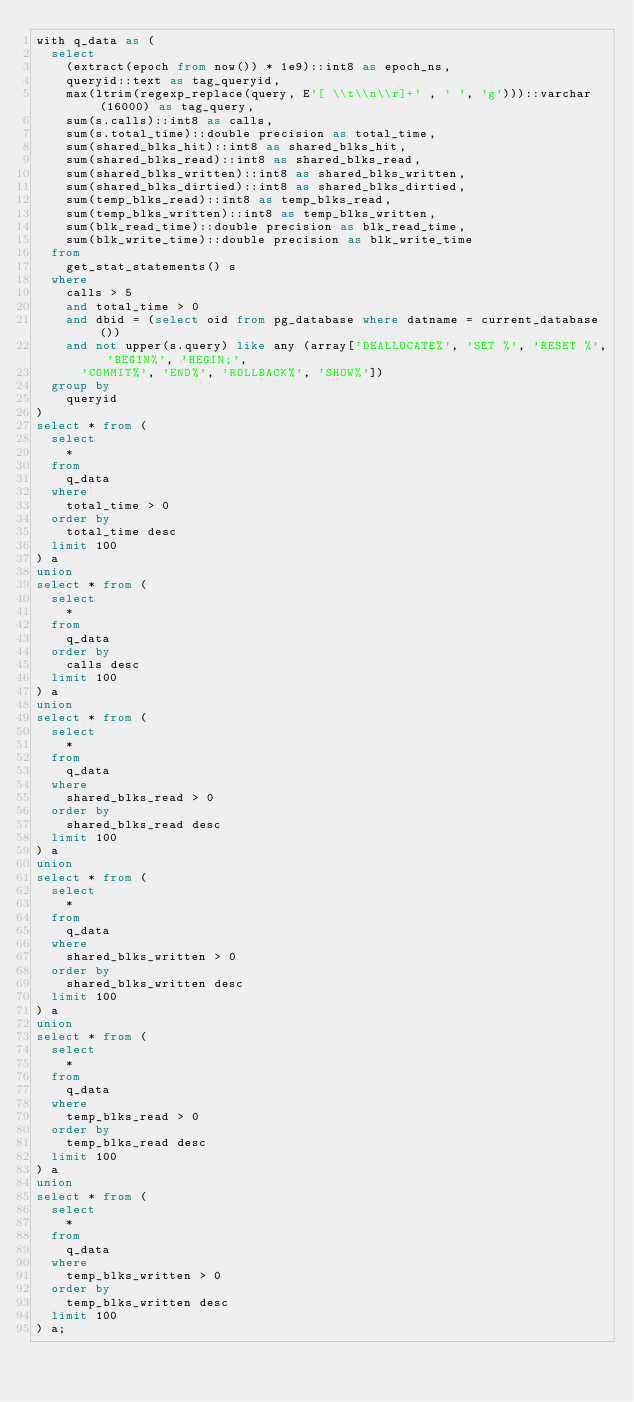Convert code to text. <code><loc_0><loc_0><loc_500><loc_500><_SQL_>with q_data as (
  select
    (extract(epoch from now()) * 1e9)::int8 as epoch_ns,
    queryid::text as tag_queryid,
    max(ltrim(regexp_replace(query, E'[ \\t\\n\\r]+' , ' ', 'g')))::varchar(16000) as tag_query,
    sum(s.calls)::int8 as calls,
    sum(s.total_time)::double precision as total_time,
    sum(shared_blks_hit)::int8 as shared_blks_hit,
    sum(shared_blks_read)::int8 as shared_blks_read,
    sum(shared_blks_written)::int8 as shared_blks_written,
    sum(shared_blks_dirtied)::int8 as shared_blks_dirtied,
    sum(temp_blks_read)::int8 as temp_blks_read,
    sum(temp_blks_written)::int8 as temp_blks_written,
    sum(blk_read_time)::double precision as blk_read_time,
    sum(blk_write_time)::double precision as blk_write_time
  from
    get_stat_statements() s
  where
    calls > 5
    and total_time > 0
    and dbid = (select oid from pg_database where datname = current_database())
    and not upper(s.query) like any (array['DEALLOCATE%', 'SET %', 'RESET %', 'BEGIN%', 'BEGIN;',
      'COMMIT%', 'END%', 'ROLLBACK%', 'SHOW%'])
  group by
    queryid
)
select * from (
  select
    *
  from
    q_data
  where
    total_time > 0
  order by
    total_time desc
  limit 100
) a
union
select * from (
  select
    *
  from
    q_data
  order by
    calls desc
  limit 100
) a
union
select * from (
  select
    *
  from
    q_data
  where
    shared_blks_read > 0
  order by
    shared_blks_read desc
  limit 100
) a
union
select * from (
  select
    *
  from
    q_data
  where
    shared_blks_written > 0
  order by
    shared_blks_written desc
  limit 100
) a
union
select * from (
  select
    *
  from
    q_data
  where
    temp_blks_read > 0
  order by
    temp_blks_read desc
  limit 100
) a
union
select * from (
  select
    *
  from
    q_data
  where
    temp_blks_written > 0
  order by
    temp_blks_written desc
  limit 100
) a;
</code> 